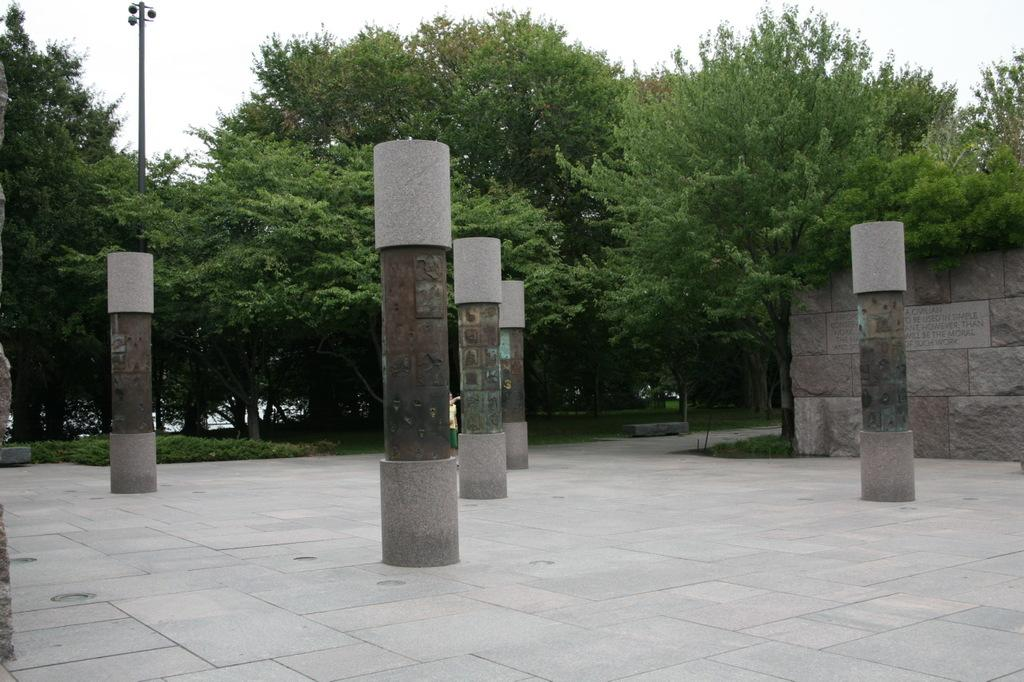What objects are on the floor in the floor in the image? There are pillars on the floor in the image. What is on top of each pillar? A: There is a metal item in the middle of each pillar. Can you describe the background of the image? In the background, there is a person standing, trees, a pole, a wall, and the sky visible. How many metal items are there in the image? There is one metal item on top of each of the pillars, so there are as many metal items as there are pillars. What is the person in the background doing? The person's actions are not clear from the image, but they are standing in the background. What type of rice is being cooked in the pot in the image? There is no pot or rice present in the image; it features pillars with metal items on top and a background with a person, trees, pole, wall, and sky. 